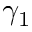<formula> <loc_0><loc_0><loc_500><loc_500>\gamma _ { 1 }</formula> 